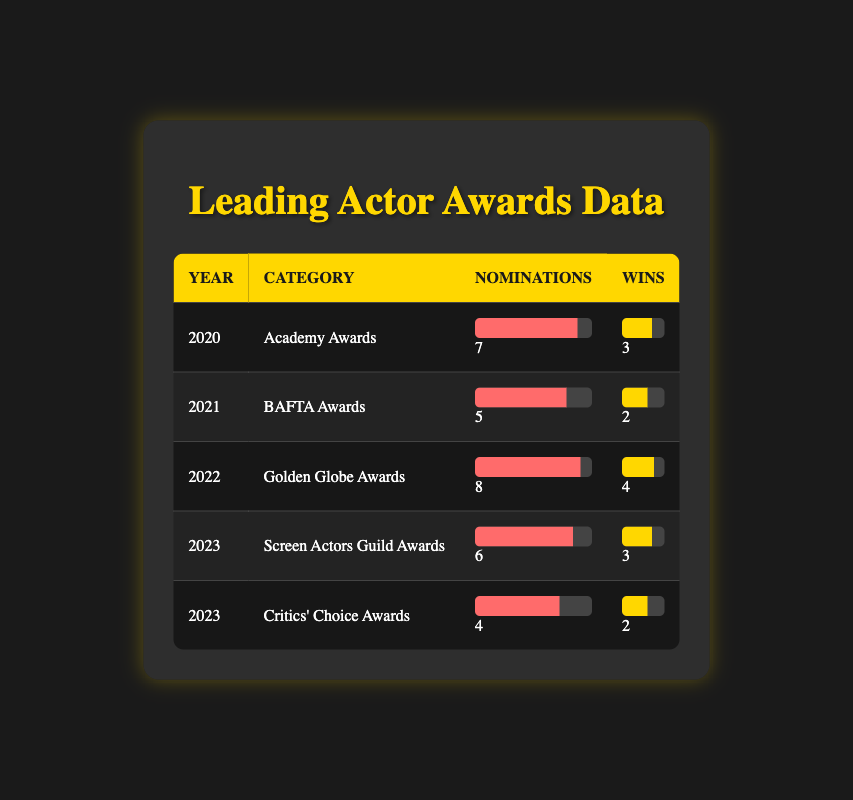What year had the highest number of nominations for leading actors? Looking at the data, the year 2022 had 8 nominations for leading actors at the Golden Globe Awards, which is the highest among all years and categories listed in the table.
Answer: 2022 How many total wins did leading actors receive in 2020 and 2023? In 2020, leading actors had 3 wins at the Academy Awards, and in 2023 there were 3 wins at the Screen Actors Guild Awards and 2 wins at the Critics' Choice Awards. Summing these gives 3 + 3 + 2 = 8.
Answer: 8 Did leading actors have more nominations than wins in 2021? In 2021, there were 5 nominations and 2 wins for leading actors at the BAFTA Awards. Since 5 nominations are greater than 2 wins, the answer is yes.
Answer: Yes What is the average number of nominations for leading actors across all years provided? To find the average, we first sum the nominations: 7 (2020) + 5 (2021) + 8 (2022) + 6 (2023 SAG) + 4 (2023 Critics' Choice) = 30. There are 5 data points, so we calculate 30/5 = 6.
Answer: 6 Which award had the least number of wins for leading actors? Reviewing the data, the BAFTA Awards in 2021 had the least number of wins, with only 2 wins for leading actors.
Answer: BAFTA Awards (2021) 